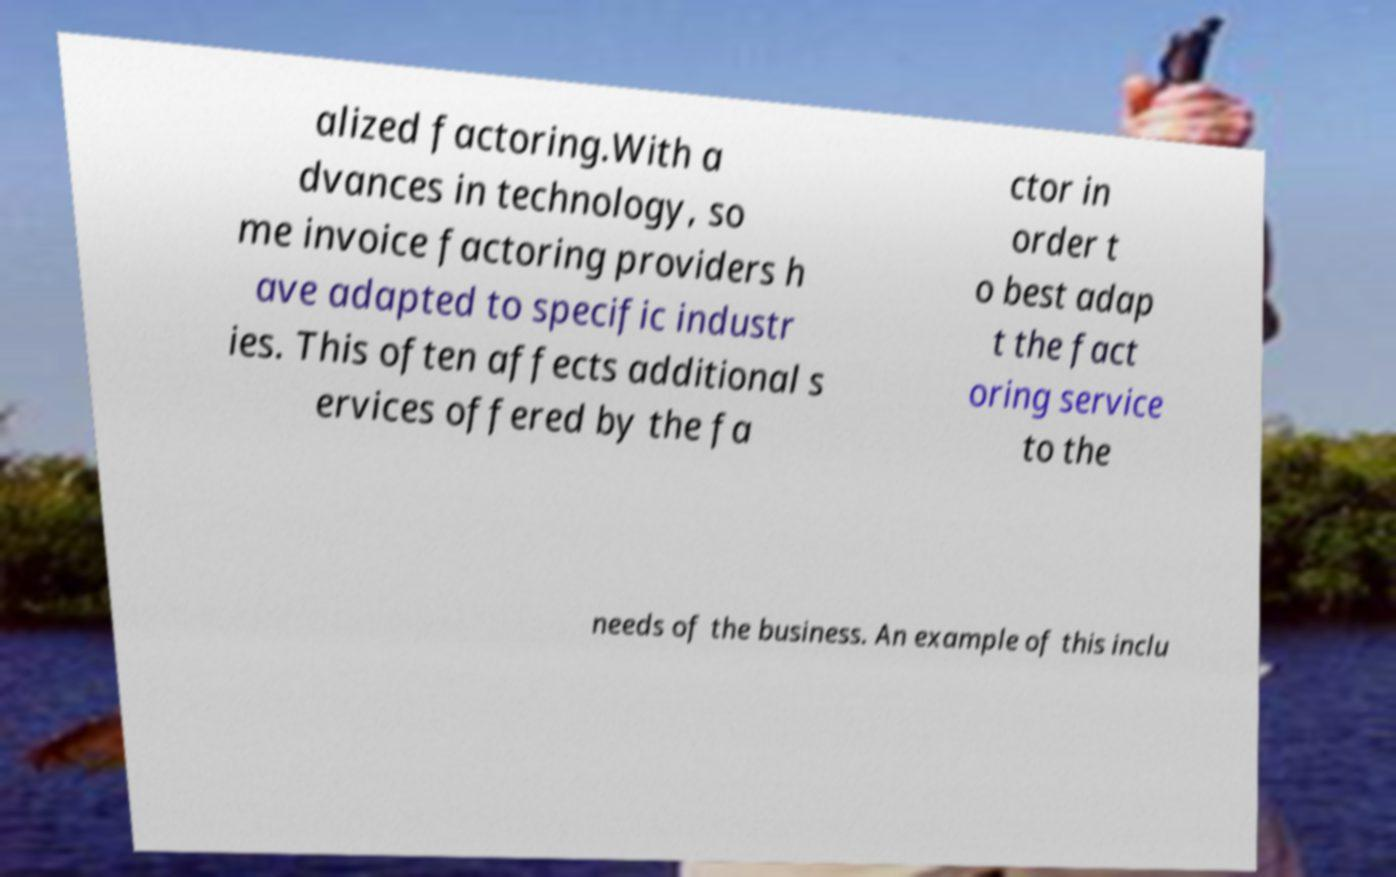Can you read and provide the text displayed in the image?This photo seems to have some interesting text. Can you extract and type it out for me? alized factoring.With a dvances in technology, so me invoice factoring providers h ave adapted to specific industr ies. This often affects additional s ervices offered by the fa ctor in order t o best adap t the fact oring service to the needs of the business. An example of this inclu 